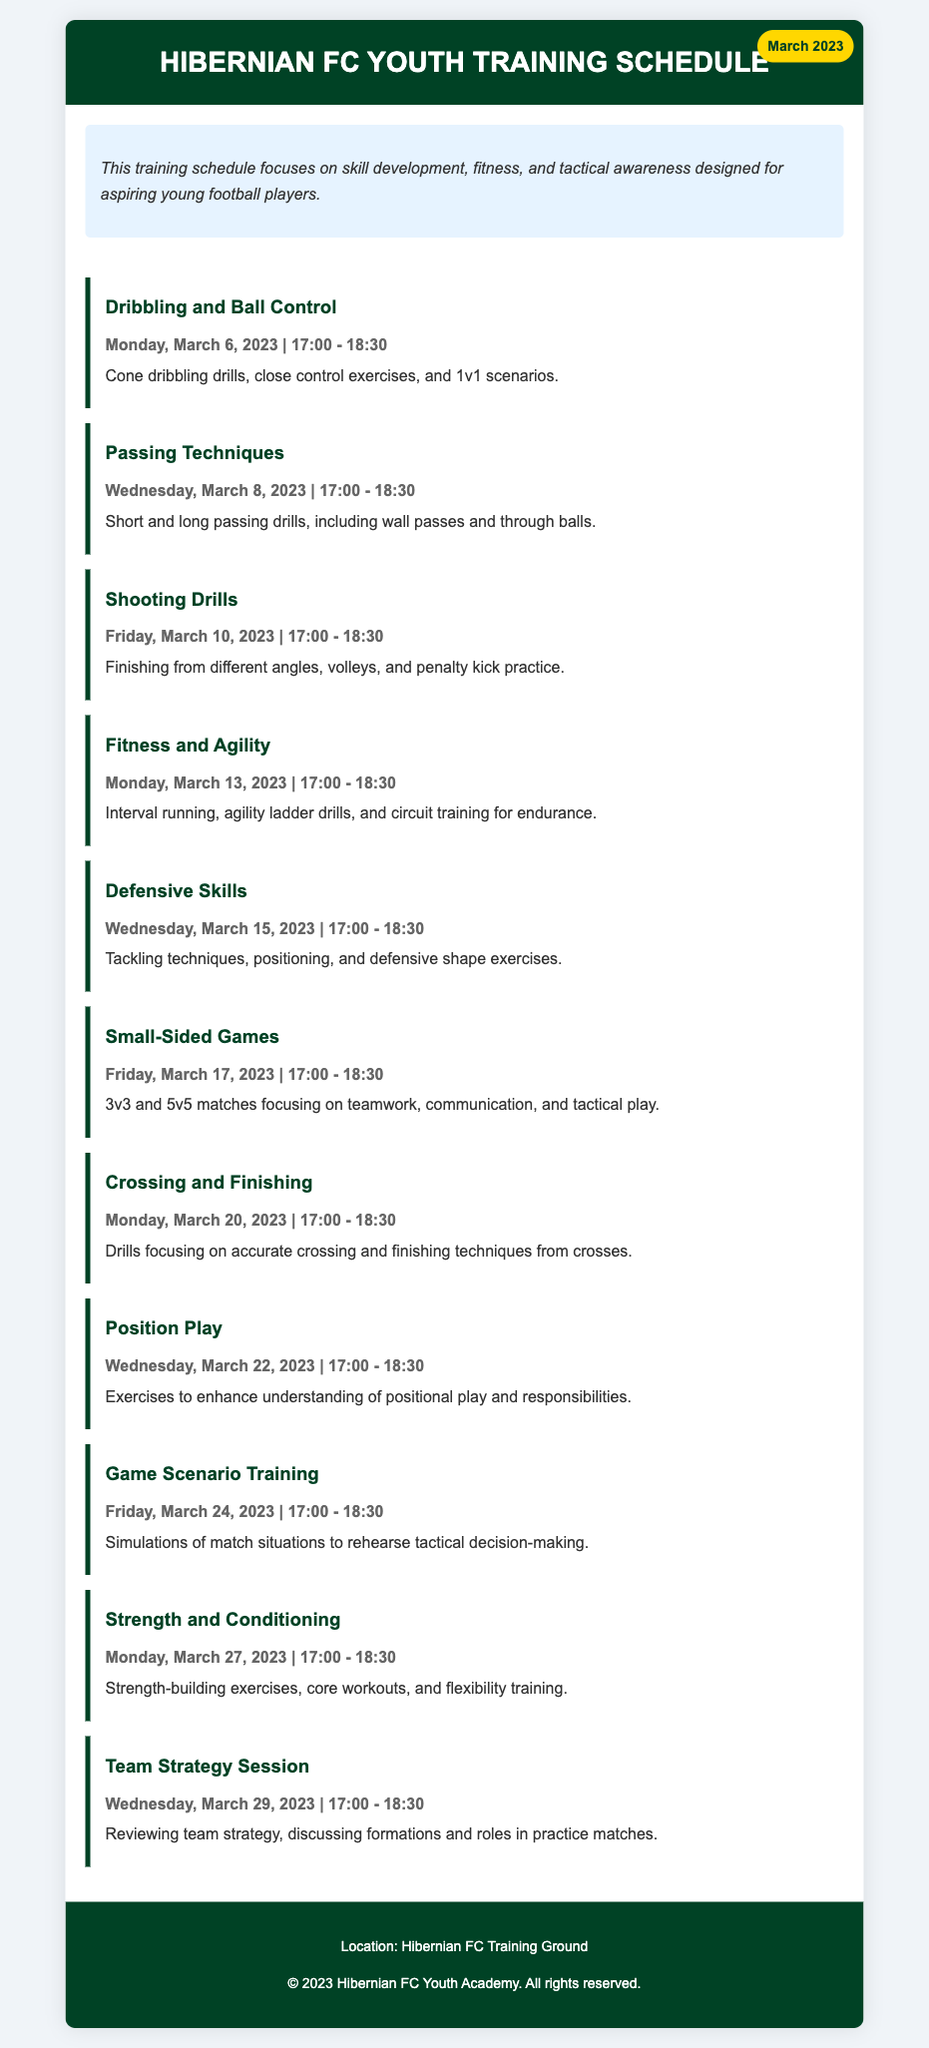What is the focus of the training schedule? The training schedule focuses on skill development, fitness, and tactical awareness designed for aspiring young football players.
Answer: skill development, fitness, and tactical awareness What day is the Shooting Drills practice scheduled? The document lists the date and time for the Shooting Drills practice on March 10, 2023.
Answer: Friday, March 10, 2023 What type of exercises are included in the Fitness and Agility session? This session comprises interval running, agility ladder drills, and circuit training for endurance.
Answer: interval running, agility ladder drills, and circuit training How many drills are scheduled in total for March? By counting the drills listed in the schedule, we find there are 10 training sessions.
Answer: 10 What skill is emphasized on March 29, 2023? The focus is on reviewing team strategy, discussing formations and roles in practice matches.
Answer: Team Strategy Session Which practice session comes after the Defensive Skills training? The session following the Defensive Skills is Small-Sided Games on March 17, 2023.
Answer: Small-Sided Games What is the time duration for each training drill? Every training session is scheduled for 1.5 hours, or 90 minutes each.
Answer: 17:00 - 18:30 What activity is scheduled for March 6, 2023? The drill scheduled for this date is Dribbling and Ball Control.
Answer: Dribbling and Ball Control What is the location of the training sessions? The training sessions are held at the Hibernian FC Training Ground.
Answer: Hibernian FC Training Ground 